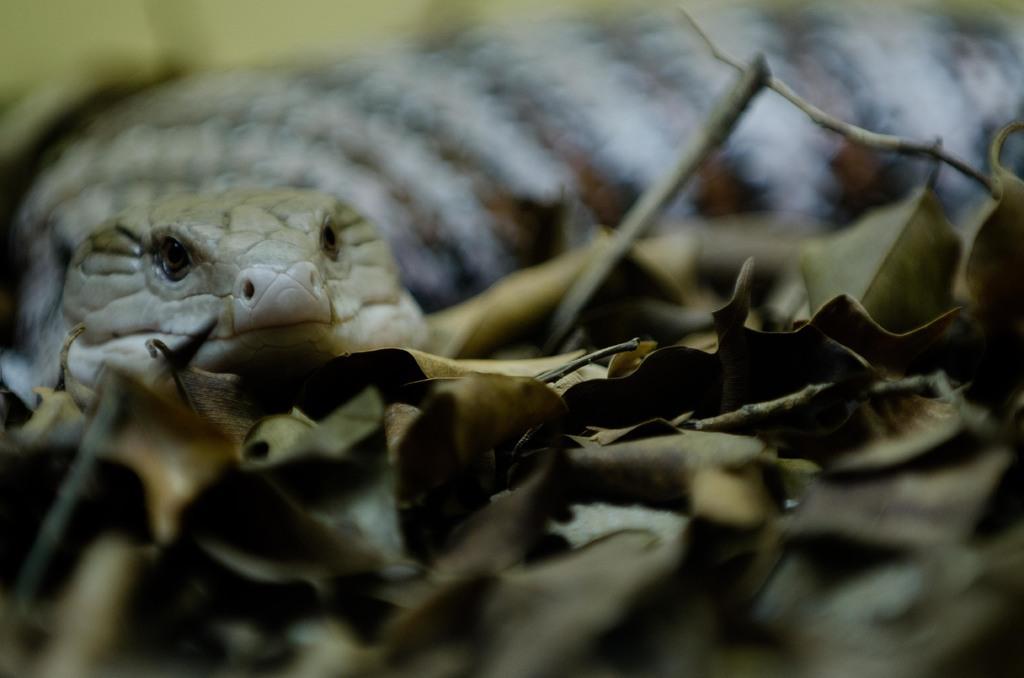Please provide a concise description of this image. In this image there is a snake on the land having few dried leaves on it. 